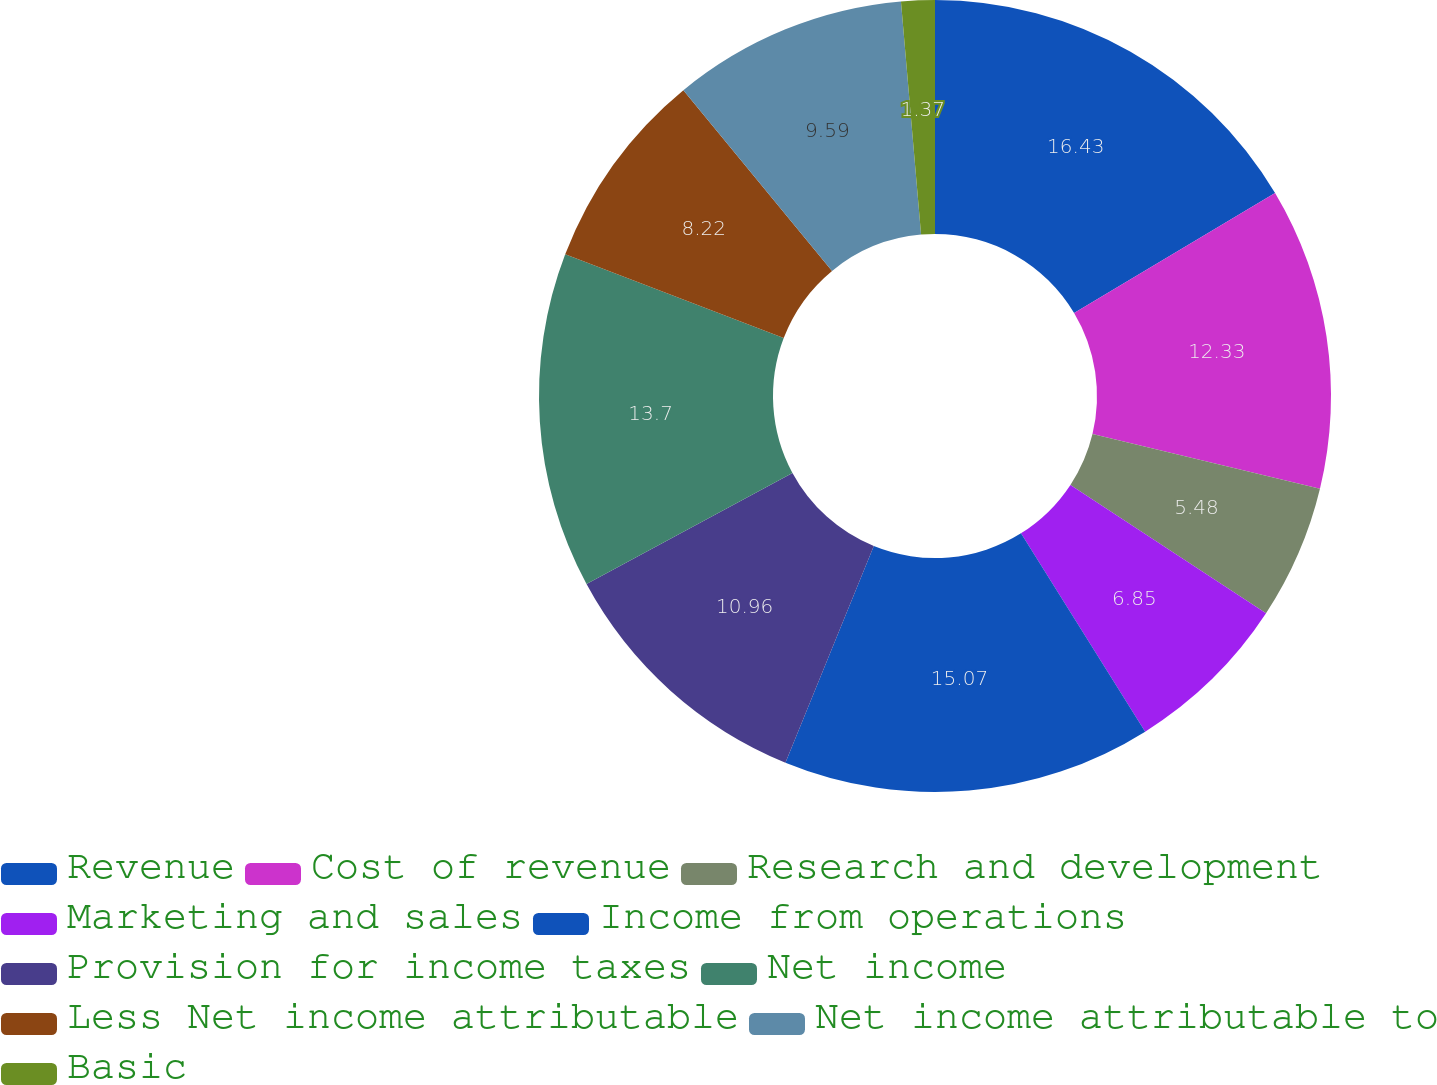Convert chart. <chart><loc_0><loc_0><loc_500><loc_500><pie_chart><fcel>Revenue<fcel>Cost of revenue<fcel>Research and development<fcel>Marketing and sales<fcel>Income from operations<fcel>Provision for income taxes<fcel>Net income<fcel>Less Net income attributable<fcel>Net income attributable to<fcel>Basic<nl><fcel>16.44%<fcel>12.33%<fcel>5.48%<fcel>6.85%<fcel>15.07%<fcel>10.96%<fcel>13.7%<fcel>8.22%<fcel>9.59%<fcel>1.37%<nl></chart> 